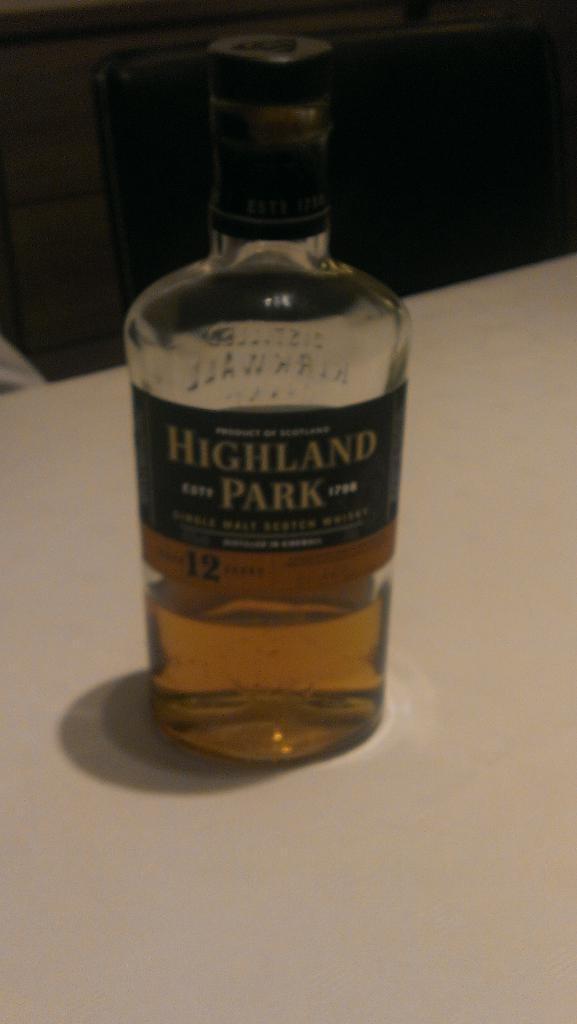What object can be seen in the image? There is a bottle in the image. Where is the bottle located? The bottle is placed on a table. How many trains are visible in the image? There are no trains present in the image; it only features a bottle placed on a table. What role does the bottle play in the digestion process? The image does not provide any information about the digestion process, and the bottle's role in it cannot be determined from the image. 